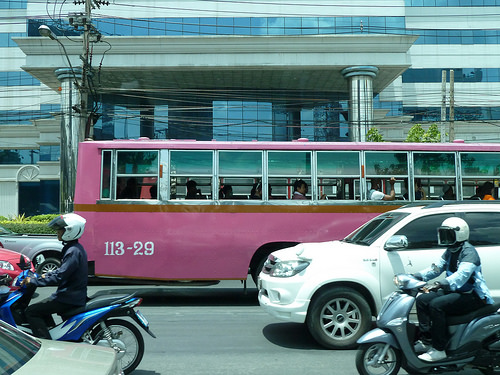<image>
Can you confirm if the bus is in front of the car? No. The bus is not in front of the car. The spatial positioning shows a different relationship between these objects. 